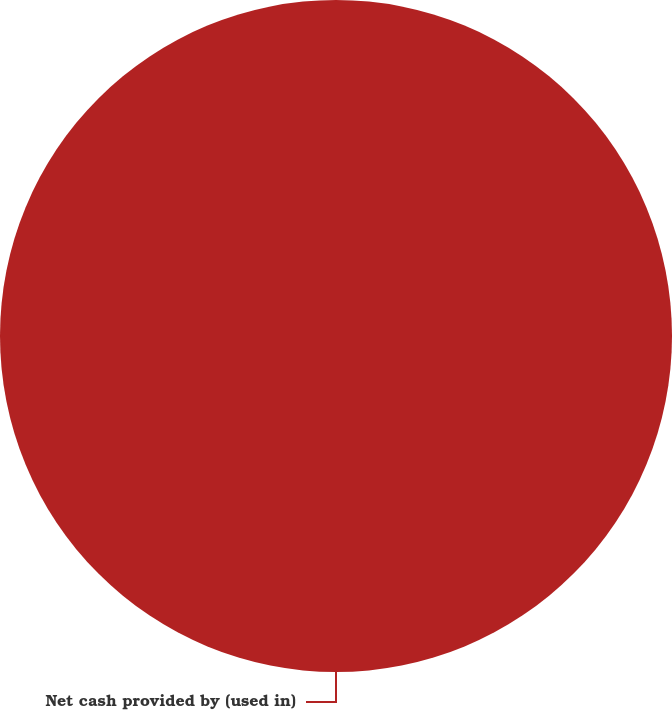Convert chart. <chart><loc_0><loc_0><loc_500><loc_500><pie_chart><fcel>Net cash provided by (used in)<nl><fcel>100.0%<nl></chart> 